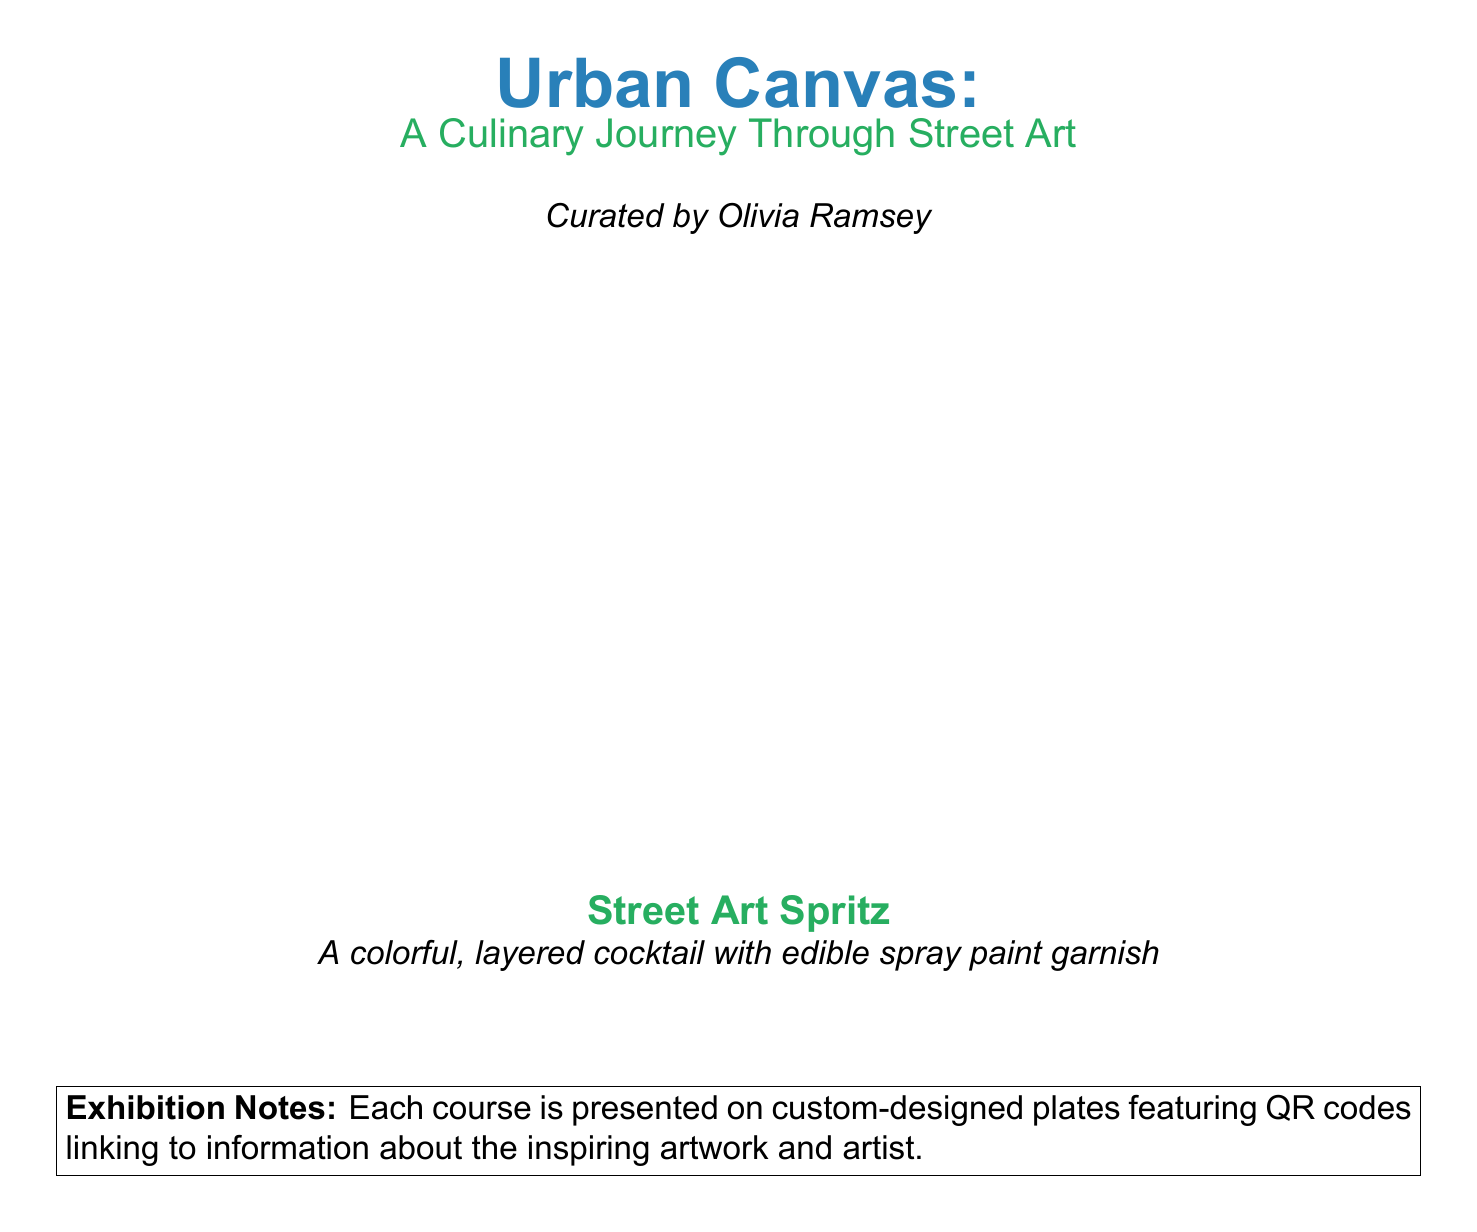What is the title of the menu? The title of the menu is displayed prominently at the top of the document.
Answer: Urban Canvas Who curated the menu? The information about the curator is mentioned below the title.
Answer: Olivia Ramsey How many courses are presented in the tasting menu? The number of courses is indicated by the range in the foreach loop in the code.
Answer: 6 What color is used for the cocktail description? The color used for the cocktail description is specified in the document.
Answer: Urbans green What does the "Street Art Spritz" consist of? The description of the cocktail reveals its components.
Answer: A colorful, layered cocktail with edible spray paint garnish What is included on the plates for each course? The document specifies what is featured on the custom-designed plates.
Answer: QR codes What note is given regarding each course? The exhibition notes section provides additional information about the presentation of the courses.
Answer: Each course is presented on custom-designed plates featuring QR codes linking to information about the inspiring artwork and artist What is the main theme of the tasting menu? The overall theme is introduced in the title and subtitle of the menu.
Answer: A Culinary Journey Through Street Art What is the significance of the QR codes? The purpose of the QR codes is explained in the exhibition notes.
Answer: Linking to information about the inspiring artwork and artist 